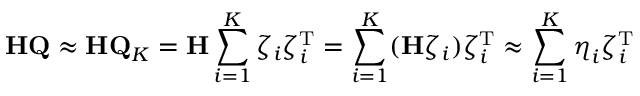Convert formula to latex. <formula><loc_0><loc_0><loc_500><loc_500>H Q \approx H Q _ { K } = H \sum _ { i = 1 } ^ { K } \zeta _ { i } \zeta _ { i } ^ { T } = \sum _ { i = 1 } ^ { K } ( H \zeta _ { i } ) \zeta _ { i } ^ { T } \approx \sum _ { i = 1 } ^ { K } \eta _ { i } \zeta _ { i } ^ { T }</formula> 